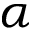Convert formula to latex. <formula><loc_0><loc_0><loc_500><loc_500>\alpha</formula> 